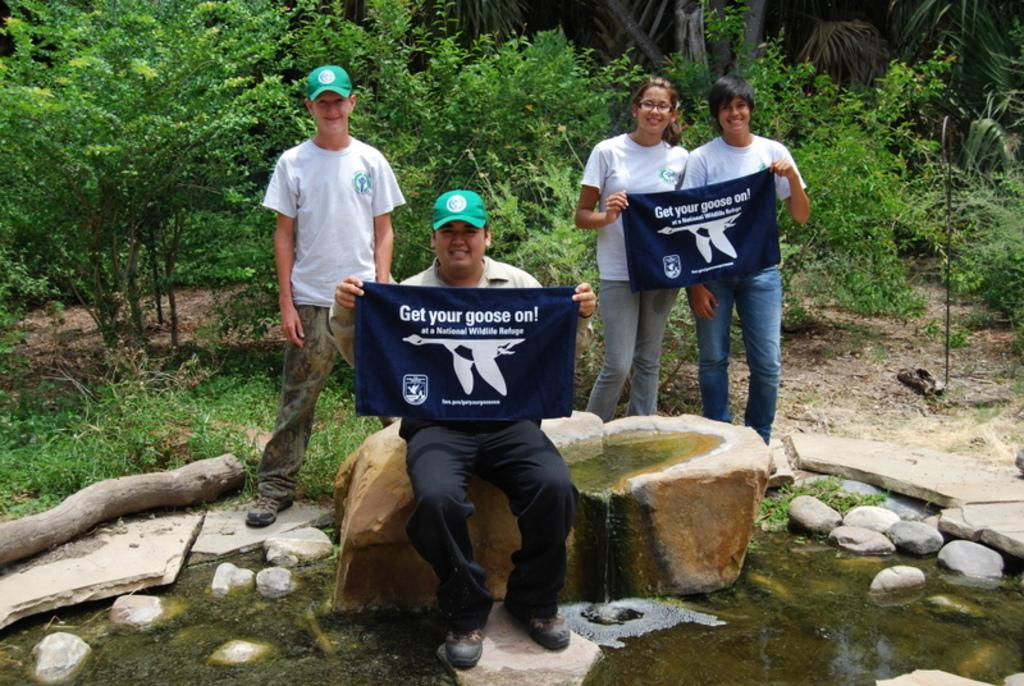<image>
Write a terse but informative summary of the picture. Some people stand at a pool, two of them holding things reading Get Your Goose On. 